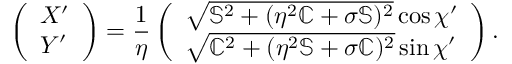<formula> <loc_0><loc_0><loc_500><loc_500>\left ( \begin{array} { l } { X ^ { \prime } } \\ { Y ^ { \prime } } \end{array} \right ) = \frac { 1 } { \eta } \left ( \begin{array} { l } { \sqrt { \mathbb { S } ^ { 2 } + ( \eta ^ { 2 } \mathbb { C } + \sigma \mathbb { S } ) ^ { 2 } } \cos \chi ^ { \prime } } \\ { \sqrt { \mathbb { C } ^ { 2 } + ( \eta ^ { 2 } \mathbb { S } + \sigma \mathbb { C } ) ^ { 2 } } \sin \chi ^ { \prime } } \end{array} \right ) .</formula> 